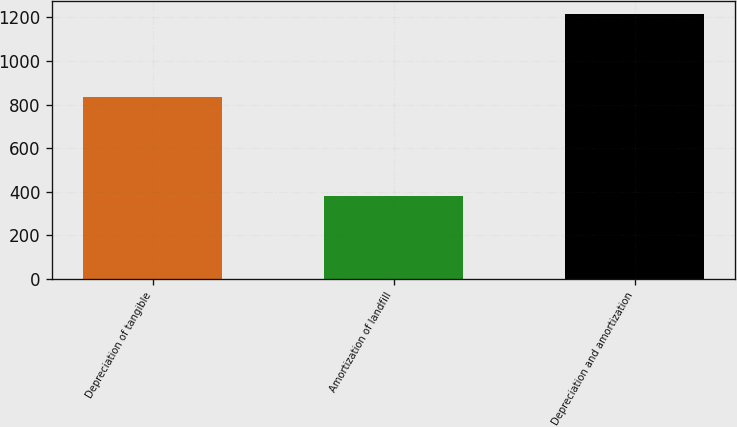Convert chart to OTSL. <chart><loc_0><loc_0><loc_500><loc_500><bar_chart><fcel>Depreciation of tangible<fcel>Amortization of landfill<fcel>Depreciation and amortization<nl><fcel>834<fcel>380<fcel>1214<nl></chart> 